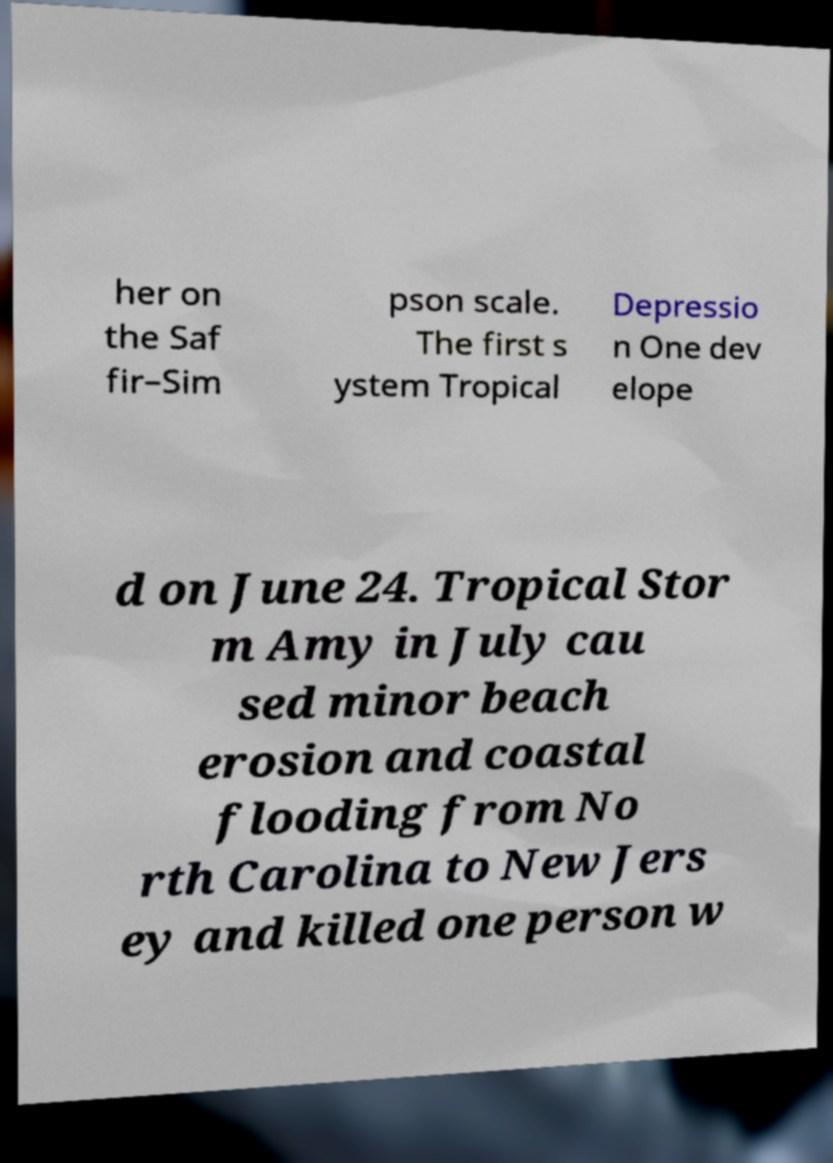Please identify and transcribe the text found in this image. her on the Saf fir–Sim pson scale. The first s ystem Tropical Depressio n One dev elope d on June 24. Tropical Stor m Amy in July cau sed minor beach erosion and coastal flooding from No rth Carolina to New Jers ey and killed one person w 